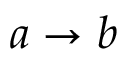<formula> <loc_0><loc_0><loc_500><loc_500>a \rightarrow b</formula> 